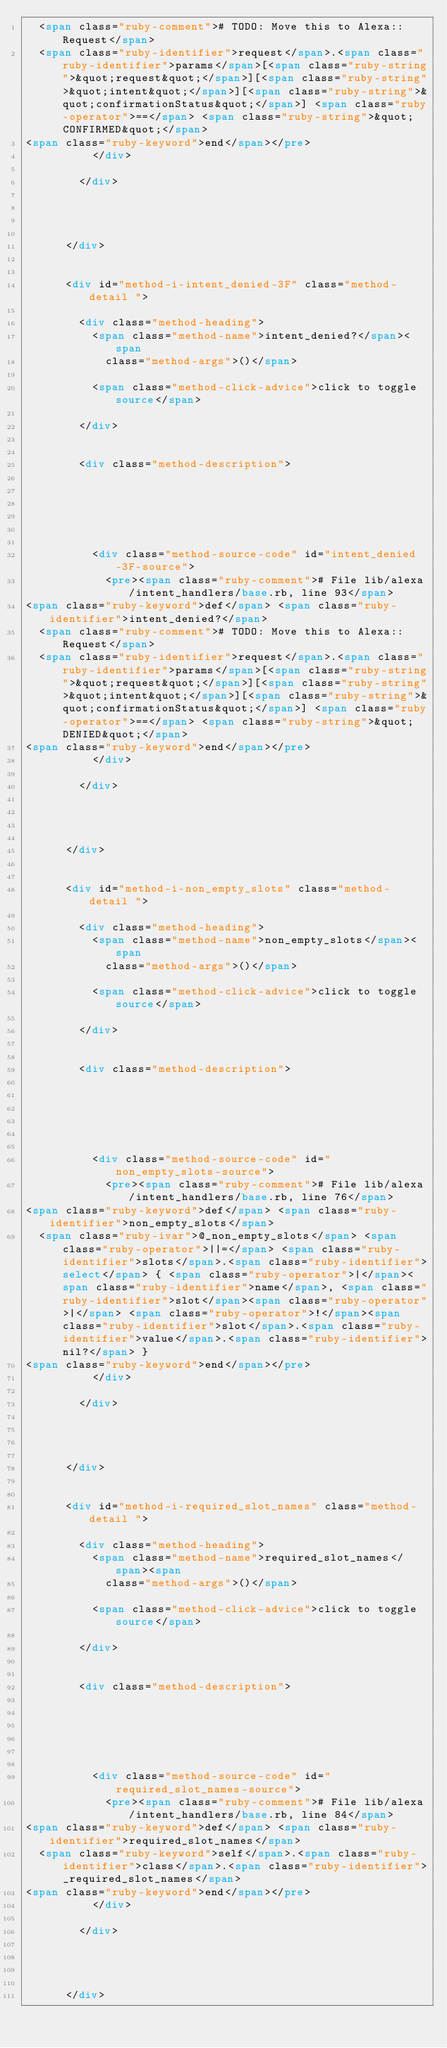<code> <loc_0><loc_0><loc_500><loc_500><_HTML_>  <span class="ruby-comment"># TODO: Move this to Alexa::Request</span>
  <span class="ruby-identifier">request</span>.<span class="ruby-identifier">params</span>[<span class="ruby-string">&quot;request&quot;</span>][<span class="ruby-string">&quot;intent&quot;</span>][<span class="ruby-string">&quot;confirmationStatus&quot;</span>] <span class="ruby-operator">==</span> <span class="ruby-string">&quot;CONFIRMED&quot;</span>
<span class="ruby-keyword">end</span></pre>
          </div>
          
        </div>

        

        
      </div>

    
      <div id="method-i-intent_denied-3F" class="method-detail ">
        
        <div class="method-heading">
          <span class="method-name">intent_denied?</span><span
            class="method-args">()</span>
          
          <span class="method-click-advice">click to toggle source</span>
          
        </div>
        

        <div class="method-description">
          
          
          
          

          
          <div class="method-source-code" id="intent_denied-3F-source">
            <pre><span class="ruby-comment"># File lib/alexa/intent_handlers/base.rb, line 93</span>
<span class="ruby-keyword">def</span> <span class="ruby-identifier">intent_denied?</span>
  <span class="ruby-comment"># TODO: Move this to Alexa::Request</span>
  <span class="ruby-identifier">request</span>.<span class="ruby-identifier">params</span>[<span class="ruby-string">&quot;request&quot;</span>][<span class="ruby-string">&quot;intent&quot;</span>][<span class="ruby-string">&quot;confirmationStatus&quot;</span>] <span class="ruby-operator">==</span> <span class="ruby-string">&quot;DENIED&quot;</span>
<span class="ruby-keyword">end</span></pre>
          </div>
          
        </div>

        

        
      </div>

    
      <div id="method-i-non_empty_slots" class="method-detail ">
        
        <div class="method-heading">
          <span class="method-name">non_empty_slots</span><span
            class="method-args">()</span>
          
          <span class="method-click-advice">click to toggle source</span>
          
        </div>
        

        <div class="method-description">
          
          
          
          

          
          <div class="method-source-code" id="non_empty_slots-source">
            <pre><span class="ruby-comment"># File lib/alexa/intent_handlers/base.rb, line 76</span>
<span class="ruby-keyword">def</span> <span class="ruby-identifier">non_empty_slots</span>
  <span class="ruby-ivar">@_non_empty_slots</span> <span class="ruby-operator">||=</span> <span class="ruby-identifier">slots</span>.<span class="ruby-identifier">select</span> { <span class="ruby-operator">|</span><span class="ruby-identifier">name</span>, <span class="ruby-identifier">slot</span><span class="ruby-operator">|</span> <span class="ruby-operator">!</span><span class="ruby-identifier">slot</span>.<span class="ruby-identifier">value</span>.<span class="ruby-identifier">nil?</span> }
<span class="ruby-keyword">end</span></pre>
          </div>
          
        </div>

        

        
      </div>

    
      <div id="method-i-required_slot_names" class="method-detail ">
        
        <div class="method-heading">
          <span class="method-name">required_slot_names</span><span
            class="method-args">()</span>
          
          <span class="method-click-advice">click to toggle source</span>
          
        </div>
        

        <div class="method-description">
          
          
          
          

          
          <div class="method-source-code" id="required_slot_names-source">
            <pre><span class="ruby-comment"># File lib/alexa/intent_handlers/base.rb, line 84</span>
<span class="ruby-keyword">def</span> <span class="ruby-identifier">required_slot_names</span>
  <span class="ruby-keyword">self</span>.<span class="ruby-identifier">class</span>.<span class="ruby-identifier">_required_slot_names</span>
<span class="ruby-keyword">end</span></pre>
          </div>
          
        </div>

        

        
      </div>
</code> 